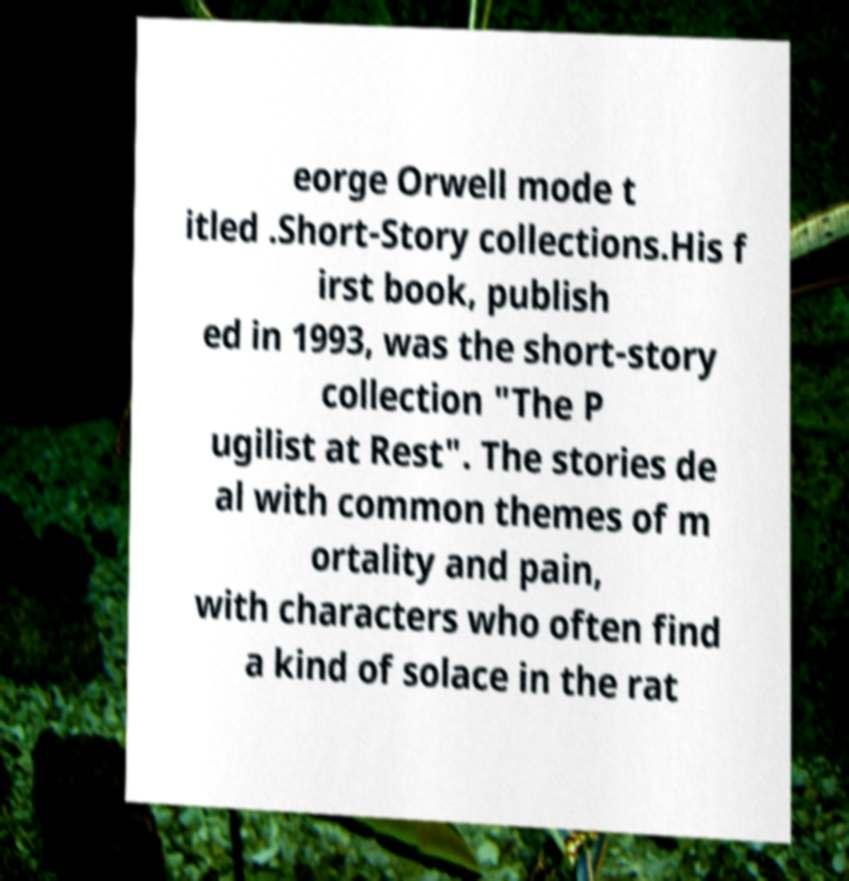Please identify and transcribe the text found in this image. eorge Orwell mode t itled .Short-Story collections.His f irst book, publish ed in 1993, was the short-story collection "The P ugilist at Rest". The stories de al with common themes of m ortality and pain, with characters who often find a kind of solace in the rat 